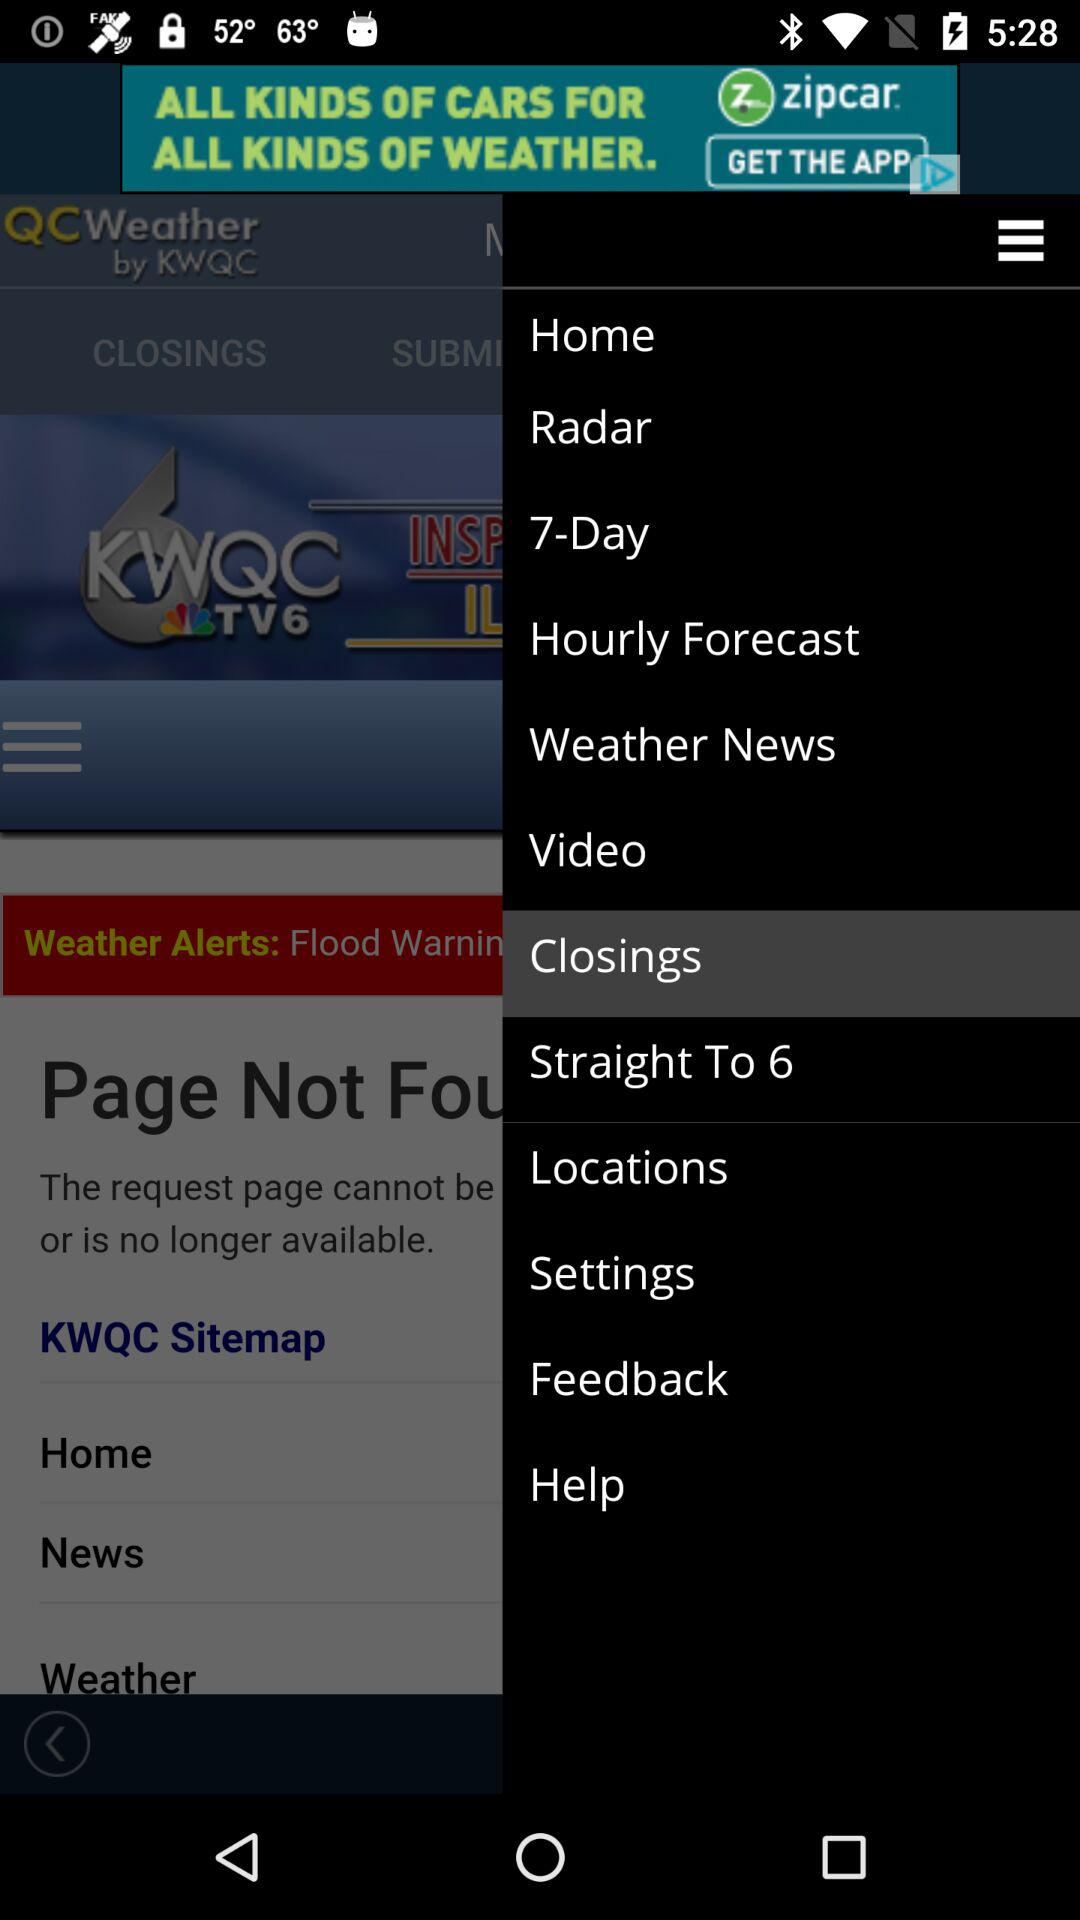Which item is selected? The selected item is "Closings". 